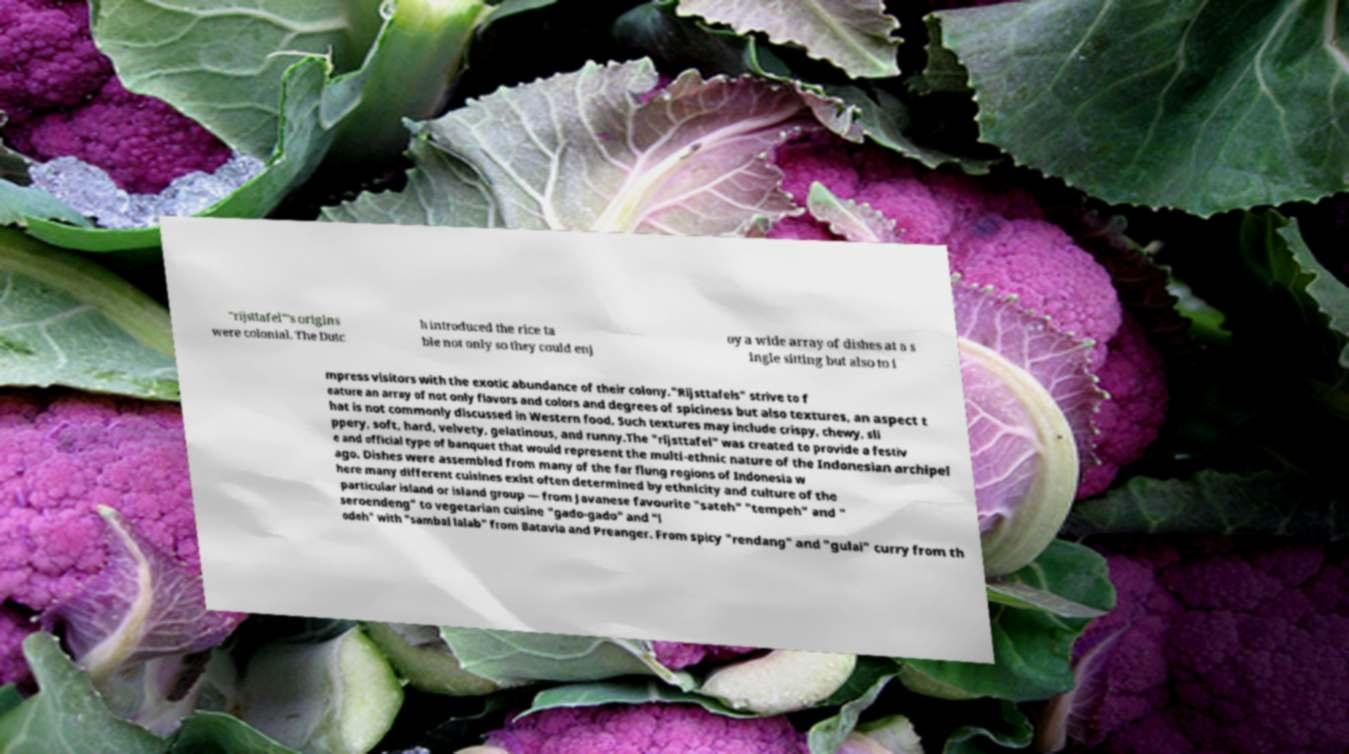There's text embedded in this image that I need extracted. Can you transcribe it verbatim? "rijsttafel"’s origins were colonial. The Dutc h introduced the rice ta ble not only so they could enj oy a wide array of dishes at a s ingle sitting but also to i mpress visitors with the exotic abundance of their colony."Rijsttafels" strive to f eature an array of not only flavors and colors and degrees of spiciness but also textures, an aspect t hat is not commonly discussed in Western food. Such textures may include crispy, chewy, sli ppery, soft, hard, velvety, gelatinous, and runny.The "rijsttafel" was created to provide a festiv e and official type of banquet that would represent the multi-ethnic nature of the Indonesian archipel ago. Dishes were assembled from many of the far flung regions of Indonesia w here many different cuisines exist often determined by ethnicity and culture of the particular island or island group — from Javanese favourite "sateh" "tempeh" and " seroendeng" to vegetarian cuisine "gado-gado" and "l odeh" with "sambal lalab" from Batavia and Preanger. From spicy "rendang" and "gulai" curry from th 